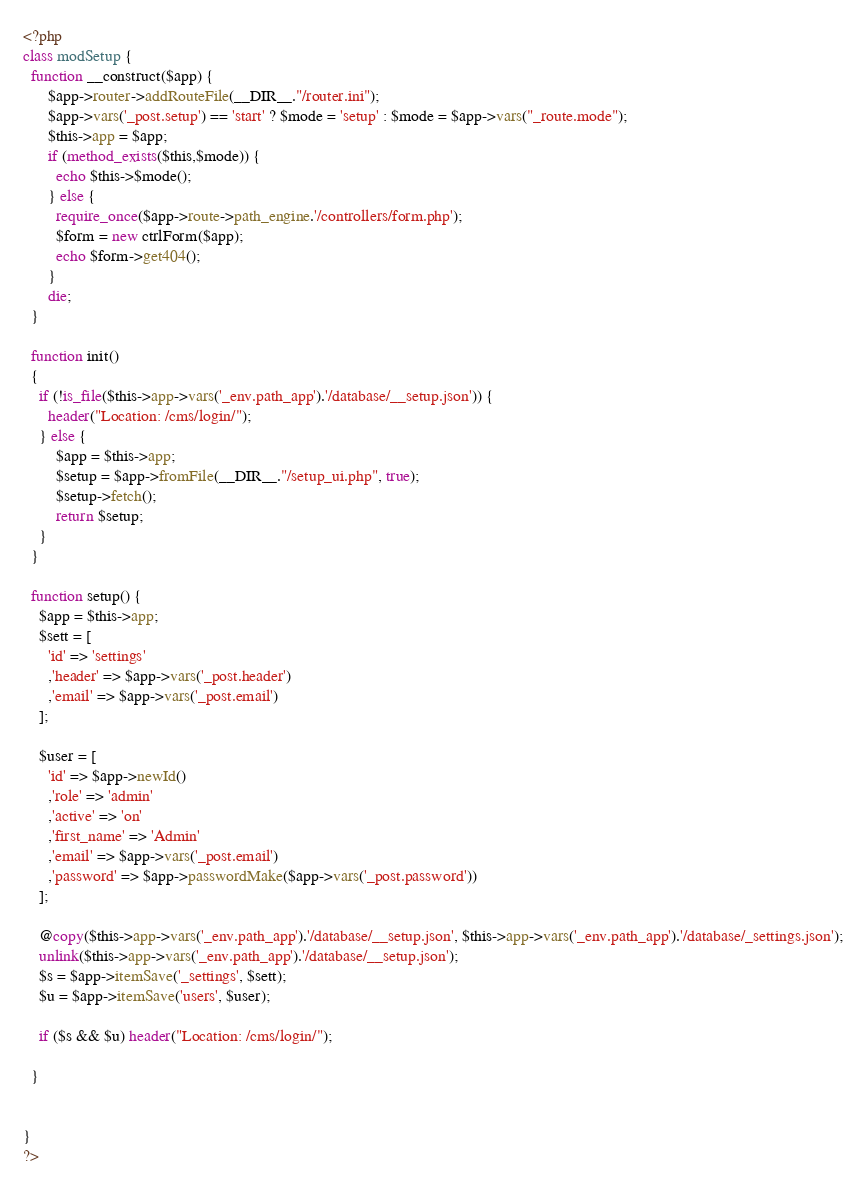<code> <loc_0><loc_0><loc_500><loc_500><_PHP_><?php
class modSetup {
  function __construct($app) {
      $app->router->addRouteFile(__DIR__."/router.ini");
      $app->vars('_post.setup') == 'start' ? $mode = 'setup' : $mode = $app->vars("_route.mode");
      $this->app = $app;
      if (method_exists($this,$mode)) {
        echo $this->$mode();
      } else {
        require_once($app->route->path_engine.'/controllers/form.php');
        $form = new ctrlForm($app);
        echo $form->get404();
      }
      die;
  }

  function init()
  {
    if (!is_file($this->app->vars('_env.path_app').'/database/__setup.json')) {
      header("Location: /cms/login/");
    } else {
        $app = $this->app;
        $setup = $app->fromFile(__DIR__."/setup_ui.php", true);
        $setup->fetch();
        return $setup;
    }
  }

  function setup() {
    $app = $this->app;
    $sett = [
      'id' => 'settings'
      ,'header' => $app->vars('_post.header')
      ,'email' => $app->vars('_post.email')
    ];

    $user = [
      'id' => $app->newId()
      ,'role' => 'admin'
      ,'active' => 'on'
      ,'first_name' => 'Admin'
      ,'email' => $app->vars('_post.email')
      ,'password' => $app->passwordMake($app->vars('_post.password'))
    ];

    @copy($this->app->vars('_env.path_app').'/database/__setup.json', $this->app->vars('_env.path_app').'/database/_settings.json');
    unlink($this->app->vars('_env.path_app').'/database/__setup.json');
    $s = $app->itemSave('_settings', $sett);
    $u = $app->itemSave('users', $user);

    if ($s && $u) header("Location: /cms/login/");

  }


}
?>
</code> 